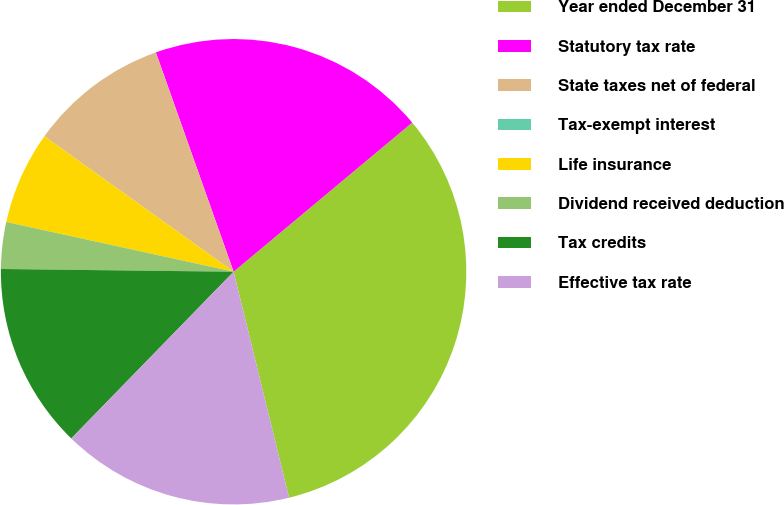<chart> <loc_0><loc_0><loc_500><loc_500><pie_chart><fcel>Year ended December 31<fcel>Statutory tax rate<fcel>State taxes net of federal<fcel>Tax-exempt interest<fcel>Life insurance<fcel>Dividend received deduction<fcel>Tax credits<fcel>Effective tax rate<nl><fcel>32.24%<fcel>19.35%<fcel>9.68%<fcel>0.01%<fcel>6.46%<fcel>3.24%<fcel>12.9%<fcel>16.12%<nl></chart> 